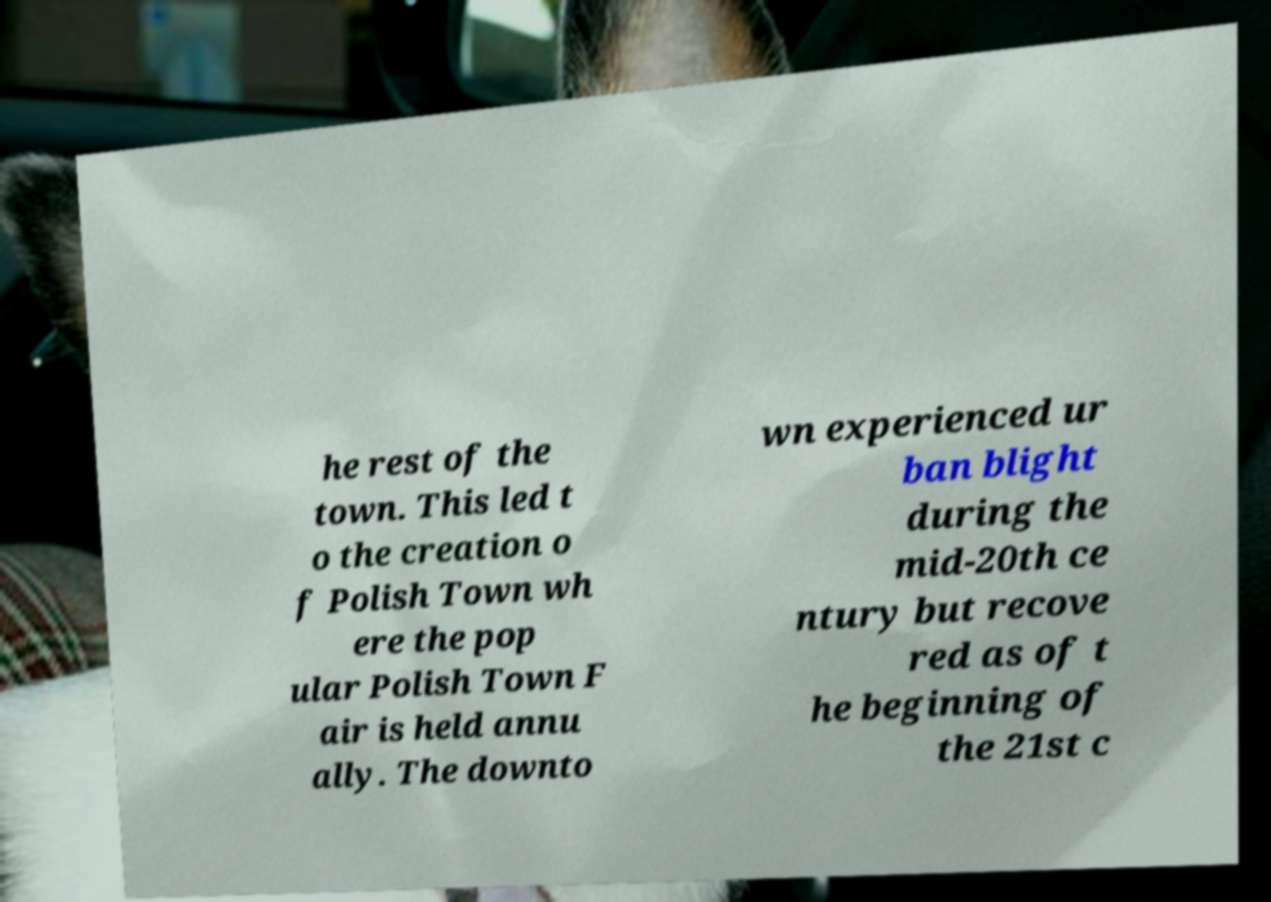Could you assist in decoding the text presented in this image and type it out clearly? he rest of the town. This led t o the creation o f Polish Town wh ere the pop ular Polish Town F air is held annu ally. The downto wn experienced ur ban blight during the mid-20th ce ntury but recove red as of t he beginning of the 21st c 